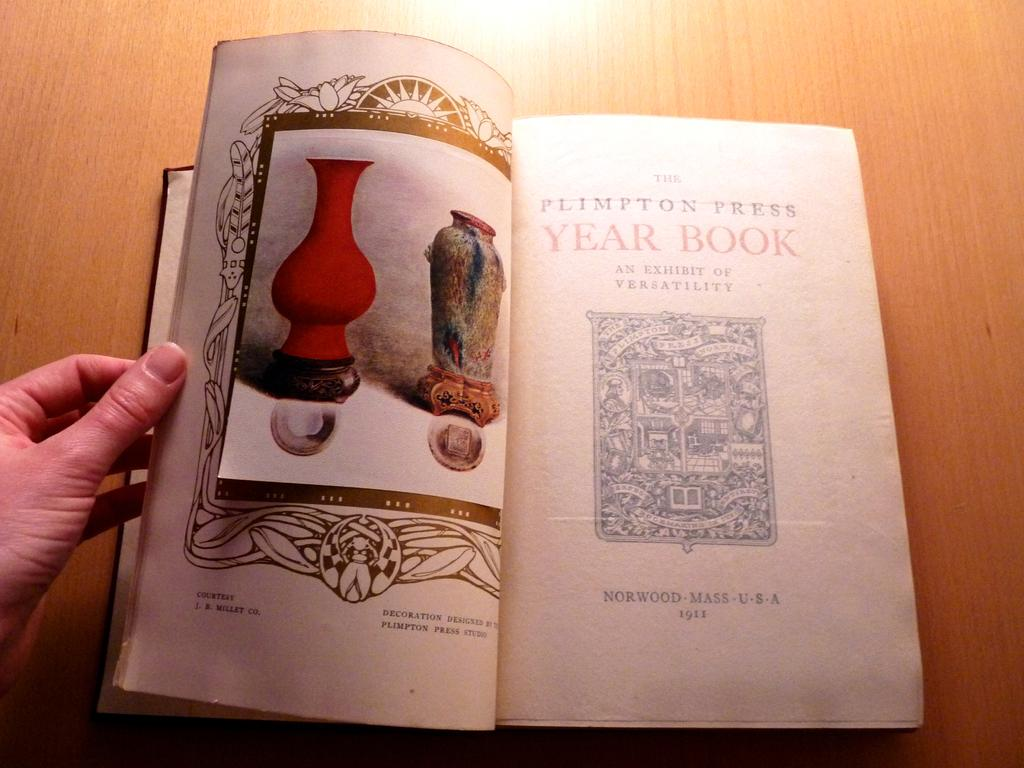<image>
Render a clear and concise summary of the photo. The Year Book has an illustration of vases on the left page and a house logo on the right page. 